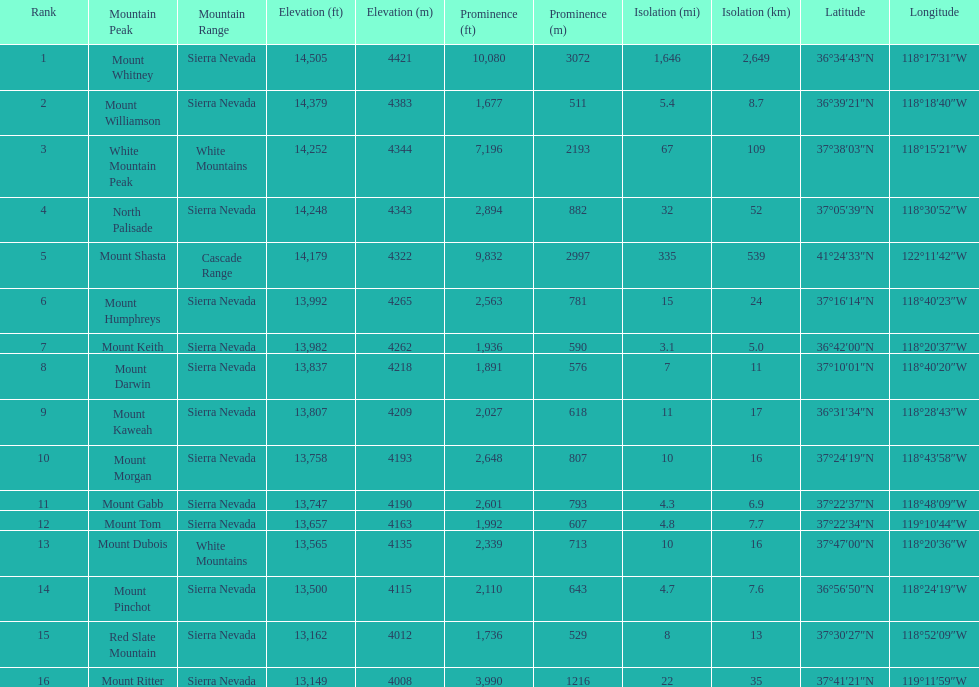Which is taller, mount humphreys or mount kaweah. Mount Humphreys. 